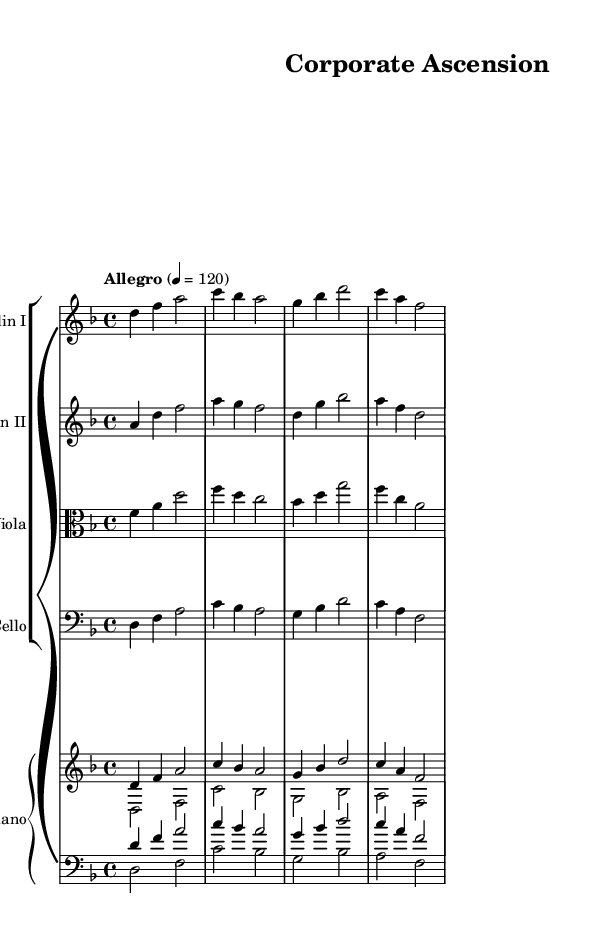What is the key signature of this music? The key signature is D minor, which has one flat noted on the sheet music.
Answer: D minor What is the time signature of this music? The time signature is 4/4, indicating that there are four beats in each measure.
Answer: 4/4 What is the tempo marking of this piece? The tempo marking is "Allegro" with a metronome marking of 120, suggesting a fast pace.
Answer: Allegro Which instruments are featured in this score? The instruments listed are Violin I, Violin II, Viola, Cello, and Piano.
Answer: Violin I, Violin II, Viola, Cello, Piano How many measures does the first violin part have? The first violin part has four measures, as indicated by the notation.
Answer: Four measures Which note value is primarily used in the piano part? The primary note value used in the piano part is the quarter note, as seen in multiple sections of the score.
Answer: Quarter note What is the overall mood suggested by the name of this piece? The mood suggested by the title "Corporate Ascension" indicates a rising, triumphant feeling, characteristic of business themes.
Answer: Triumphant 